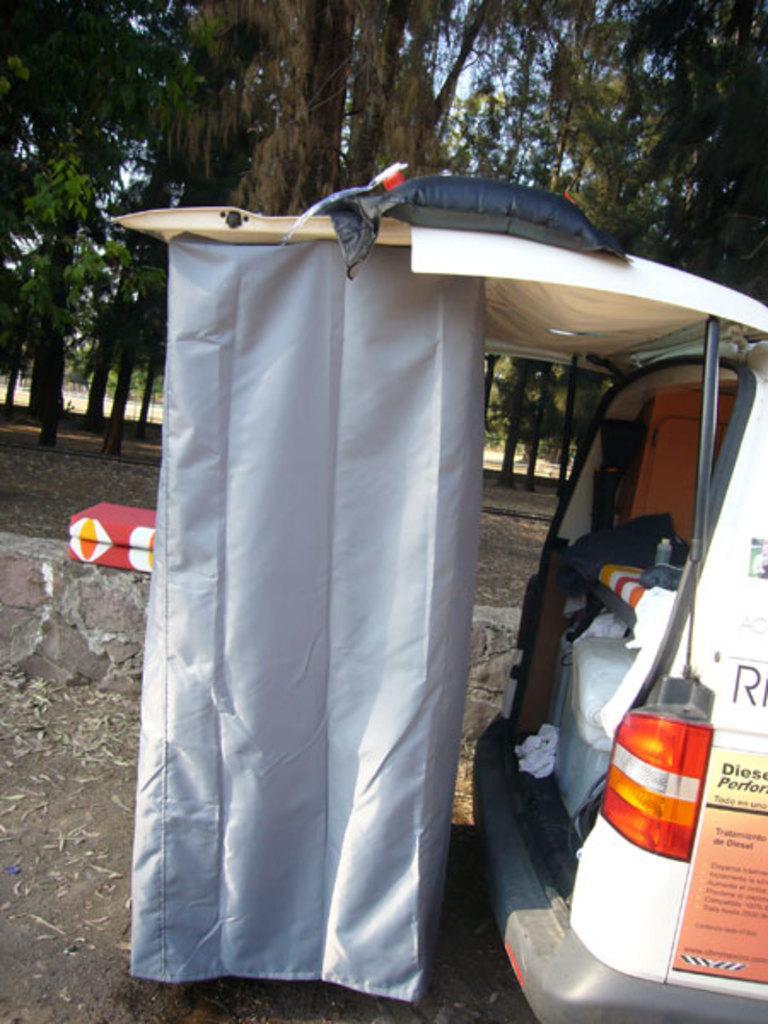Could you give a brief overview of what you see in this image? There is a vehicle. On the back door of the vehicle there is a cloth. Inside the vehicle there are some items. In the background there are trees. 